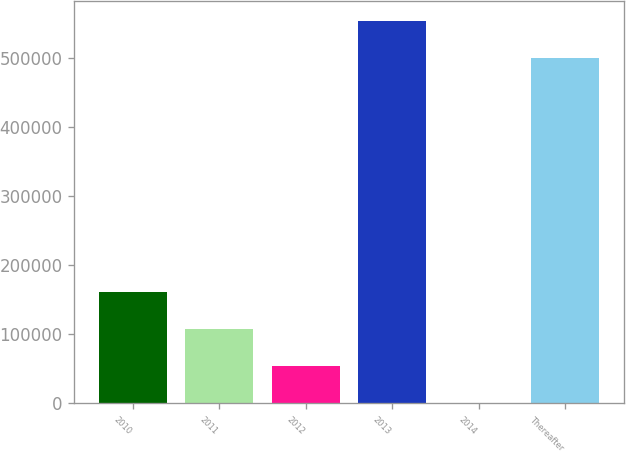Convert chart to OTSL. <chart><loc_0><loc_0><loc_500><loc_500><bar_chart><fcel>2010<fcel>2011<fcel>2012<fcel>2013<fcel>2014<fcel>Thereafter<nl><fcel>161437<fcel>107744<fcel>54051<fcel>554723<fcel>358<fcel>501030<nl></chart> 